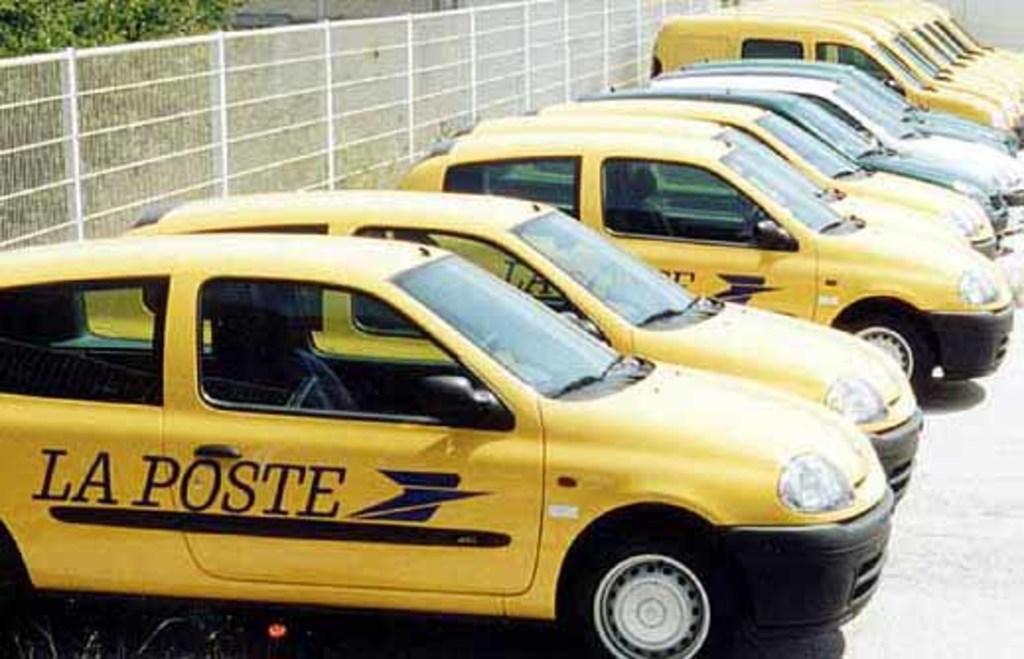What brand of cars are those?
Offer a terse response. La poste. What do those guys work for?
Your answer should be very brief. La poste. 